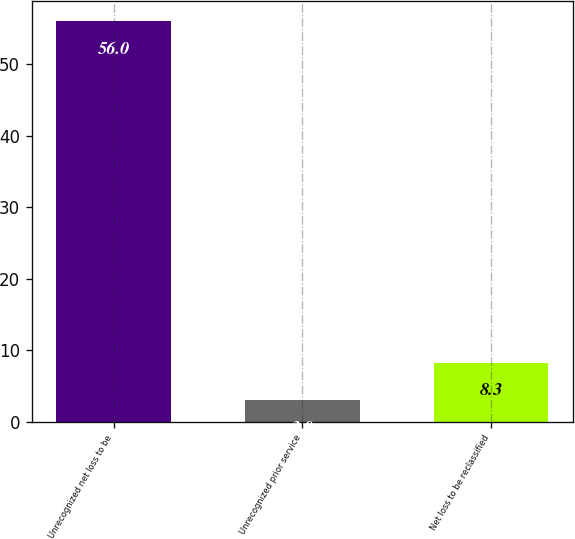Convert chart. <chart><loc_0><loc_0><loc_500><loc_500><bar_chart><fcel>Unrecognized net loss to be<fcel>Unrecognized prior service<fcel>Net loss to be reclassified<nl><fcel>56<fcel>3<fcel>8.3<nl></chart> 